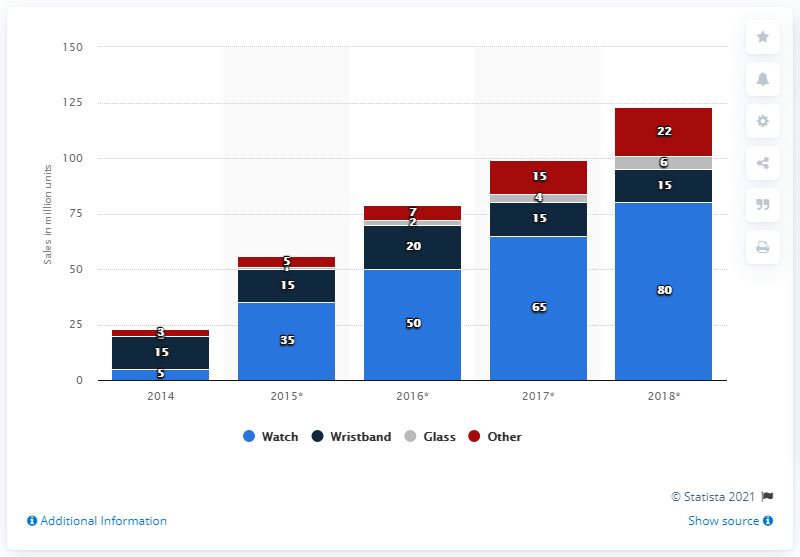Specify some key components in this picture. In 2014, a total of 15 smart wristbands were sold. 